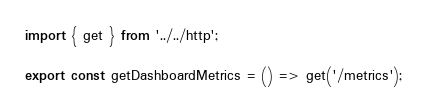<code> <loc_0><loc_0><loc_500><loc_500><_JavaScript_>import { get } from '../../http';

export const getDashboardMetrics = () => get('/metrics');
</code> 